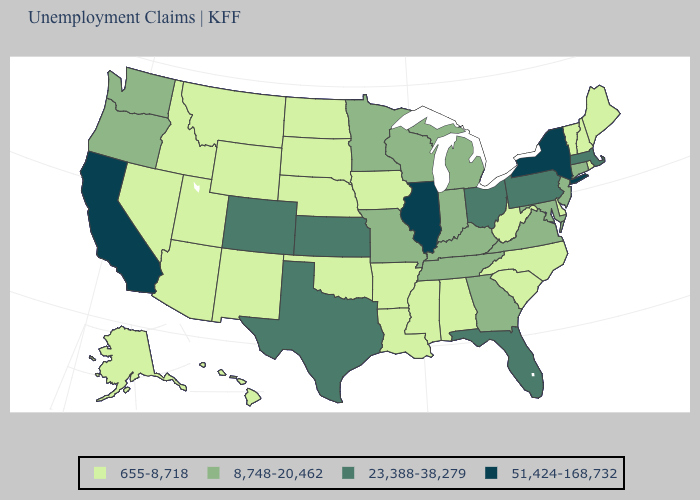Among the states that border West Virginia , does Pennsylvania have the highest value?
Quick response, please. Yes. What is the value of New Jersey?
Concise answer only. 8,748-20,462. What is the value of Florida?
Be succinct. 23,388-38,279. What is the value of Alabama?
Answer briefly. 655-8,718. What is the value of Ohio?
Answer briefly. 23,388-38,279. Does New Jersey have the highest value in the Northeast?
Give a very brief answer. No. Among the states that border Kentucky , does West Virginia have the highest value?
Be succinct. No. What is the lowest value in the South?
Answer briefly. 655-8,718. Which states have the highest value in the USA?
Quick response, please. California, Illinois, New York. Which states have the lowest value in the South?
Give a very brief answer. Alabama, Arkansas, Delaware, Louisiana, Mississippi, North Carolina, Oklahoma, South Carolina, West Virginia. Does Georgia have the lowest value in the South?
Short answer required. No. Among the states that border Missouri , which have the highest value?
Keep it brief. Illinois. What is the value of Montana?
Short answer required. 655-8,718. What is the value of New Mexico?
Short answer required. 655-8,718. 